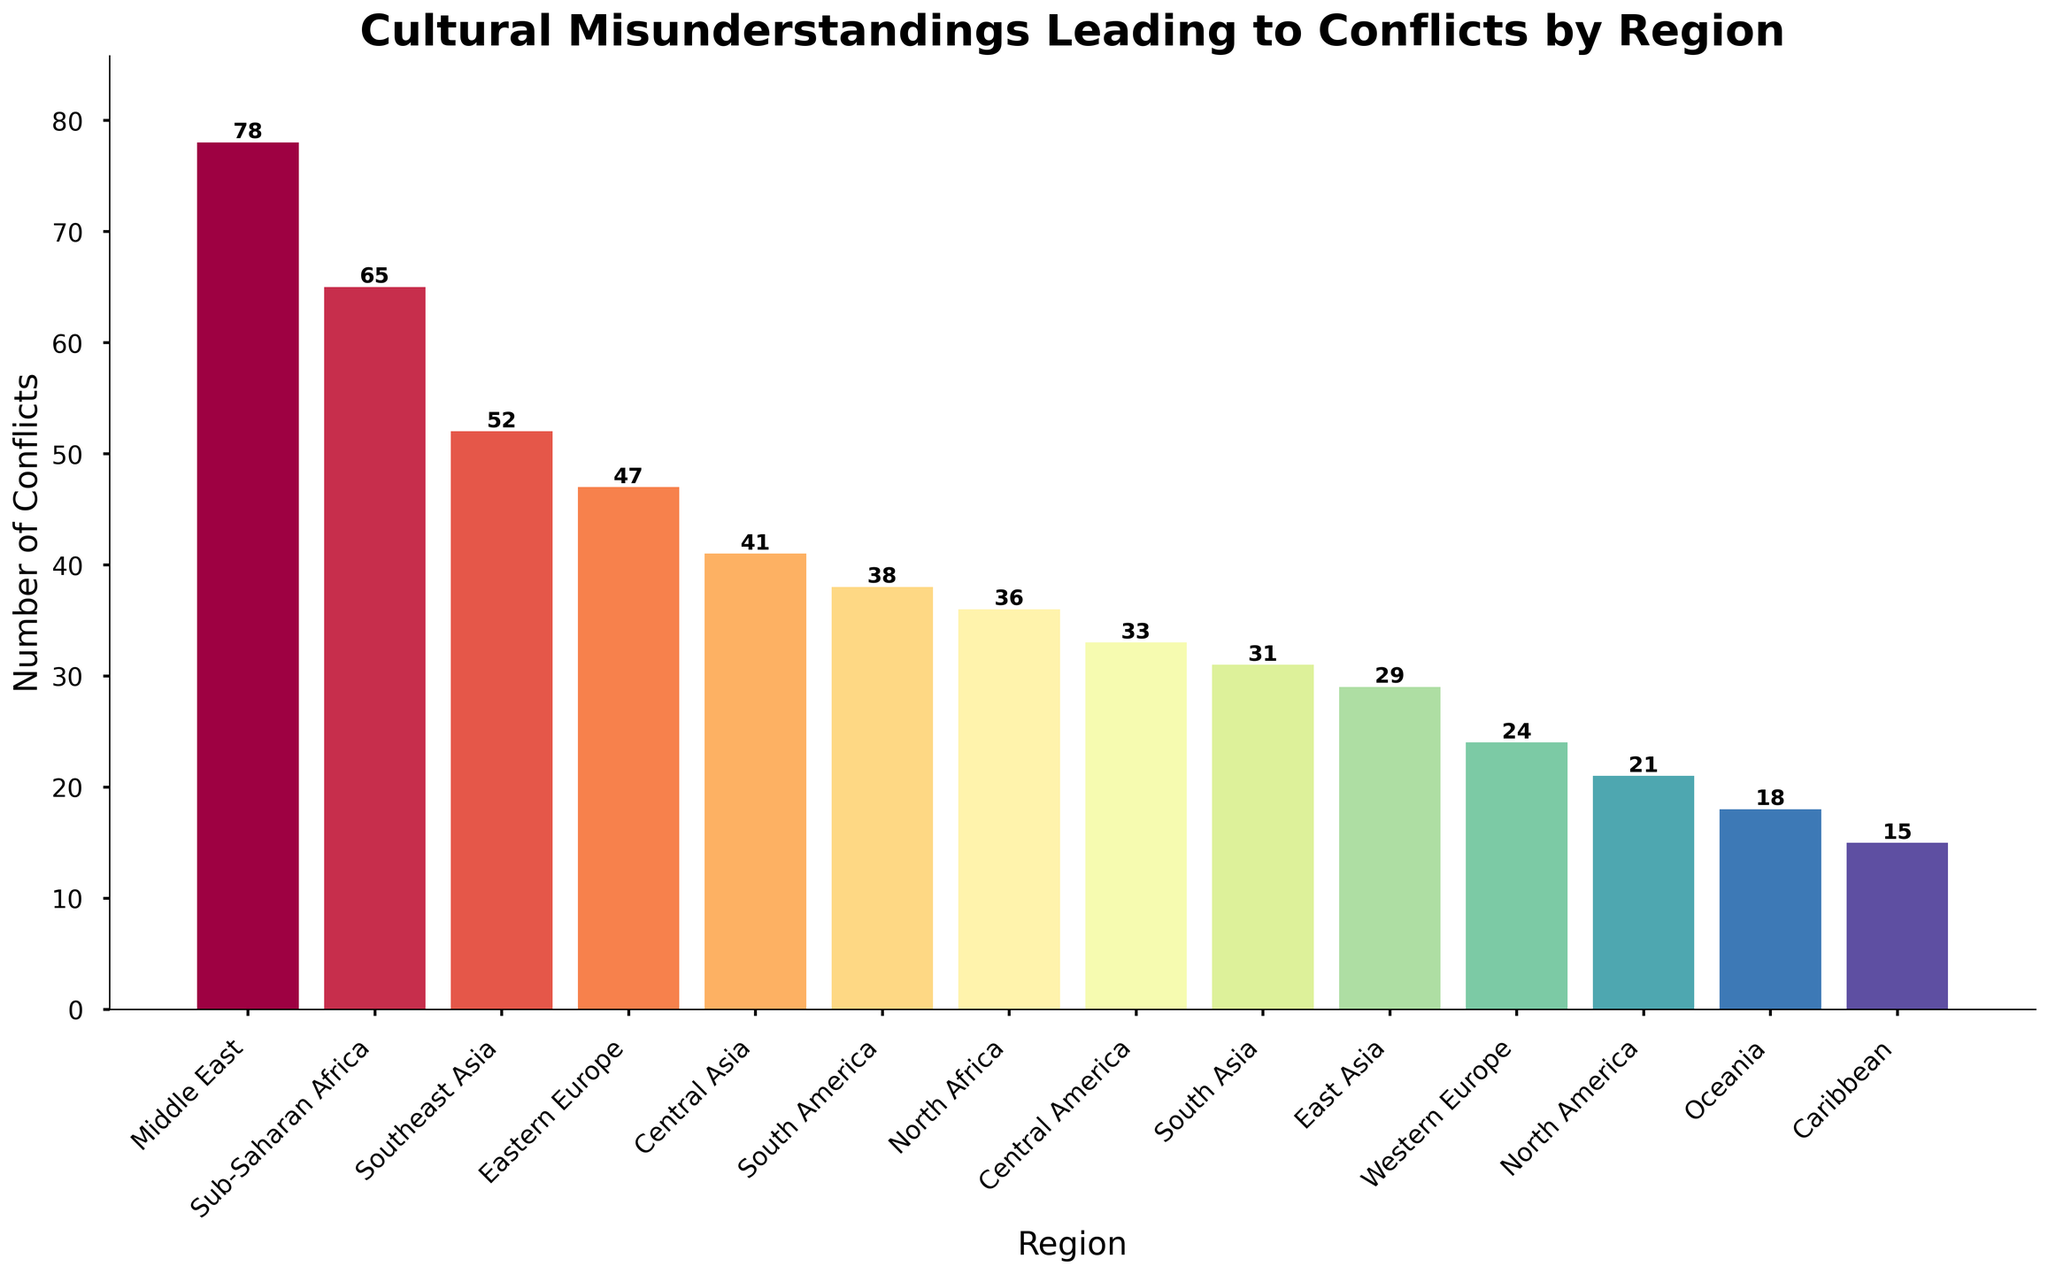what region has the highest number of cultural misunderstandings leading to conflicts? The Middle East has the tallest bar of all the regions, indicating it has the highest number of cultural misunderstandings leading to conflicts, which is labeled as 78
Answer: Middle East Which two regions have the closest number of conflicts, and what is that number? North Africa and Central America have very close numbers of conflicts, with North Africa having 36 conflicts and Central America having 33
Answer: North Africa and Central America, 36 and 33 How many more conflicts are there in Sub-Saharan Africa compared to North America? Sub-Saharan Africa has 65 conflicts, and North America has 21. The difference between them is 65 - 21 = 44
Answer: 44 What is the total number of cultural misunderstandings leading to conflicts in all the regions combined? The total number is computed by summing all the conflict numbers: 78 + 65 + 52 + 47 + 41 + 38 + 36 + 33 + 31 + 29 + 24 + 21 + 18 + 15 = 528
Answer: 528 Which region has fewer conflicts, South Asia or East Asia, and by how much? East Asia has 29 conflicts, and South Asia has 31. The difference is 31 - 29 = 2, so East Asia has 2 fewer conflicts than South Asia
Answer: East Asia, 2 What is the average number of conflicts across all regions? The total number of conflicts is 528, and there are 14 regions. The average is calculated as 528 / 14 = 37.71
Answer: 37.71 Among North America, Oceania, and the Caribbean, which has the fewest number of conflicts? The Caribbean has the fewest number of conflicts with a value of 15 compared to North America's 21 and Oceania's 18
Answer: Caribbean 